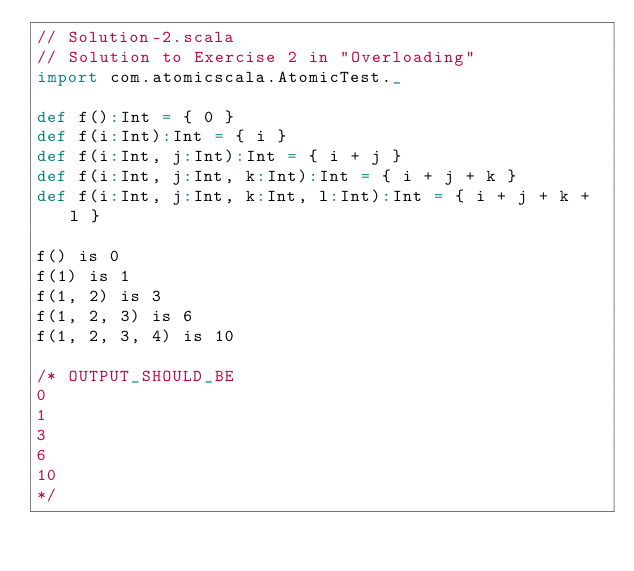<code> <loc_0><loc_0><loc_500><loc_500><_Scala_>// Solution-2.scala
// Solution to Exercise 2 in "Overloading"
import com.atomicscala.AtomicTest._

def f():Int = { 0 }
def f(i:Int):Int = { i }
def f(i:Int, j:Int):Int = { i + j }
def f(i:Int, j:Int, k:Int):Int = { i + j + k }
def f(i:Int, j:Int, k:Int, l:Int):Int = { i + j + k + l }

f() is 0
f(1) is 1
f(1, 2) is 3
f(1, 2, 3) is 6
f(1, 2, 3, 4) is 10

/* OUTPUT_SHOULD_BE
0
1
3
6
10
*/
</code> 